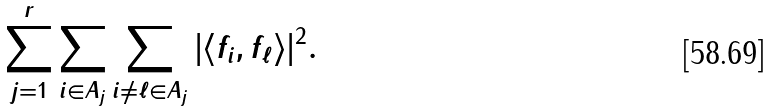Convert formula to latex. <formula><loc_0><loc_0><loc_500><loc_500>\sum _ { j = 1 } ^ { r } \sum _ { i \in A _ { j } } \sum _ { i \not = \ell \in A _ { j } } | \langle f _ { i } , f _ { \ell } \rangle | ^ { 2 } .</formula> 